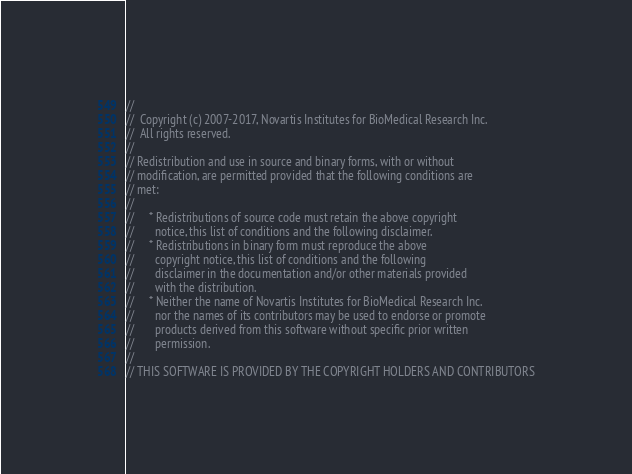<code> <loc_0><loc_0><loc_500><loc_500><_C++_>//
//  Copyright (c) 2007-2017, Novartis Institutes for BioMedical Research Inc.
//  All rights reserved.
//
// Redistribution and use in source and binary forms, with or without
// modification, are permitted provided that the following conditions are
// met:
//
//     * Redistributions of source code must retain the above copyright
//       notice, this list of conditions and the following disclaimer.
//     * Redistributions in binary form must reproduce the above
//       copyright notice, this list of conditions and the following
//       disclaimer in the documentation and/or other materials provided
//       with the distribution.
//     * Neither the name of Novartis Institutes for BioMedical Research Inc.
//       nor the names of its contributors may be used to endorse or promote
//       products derived from this software without specific prior written
//       permission.
//
// THIS SOFTWARE IS PROVIDED BY THE COPYRIGHT HOLDERS AND CONTRIBUTORS</code> 